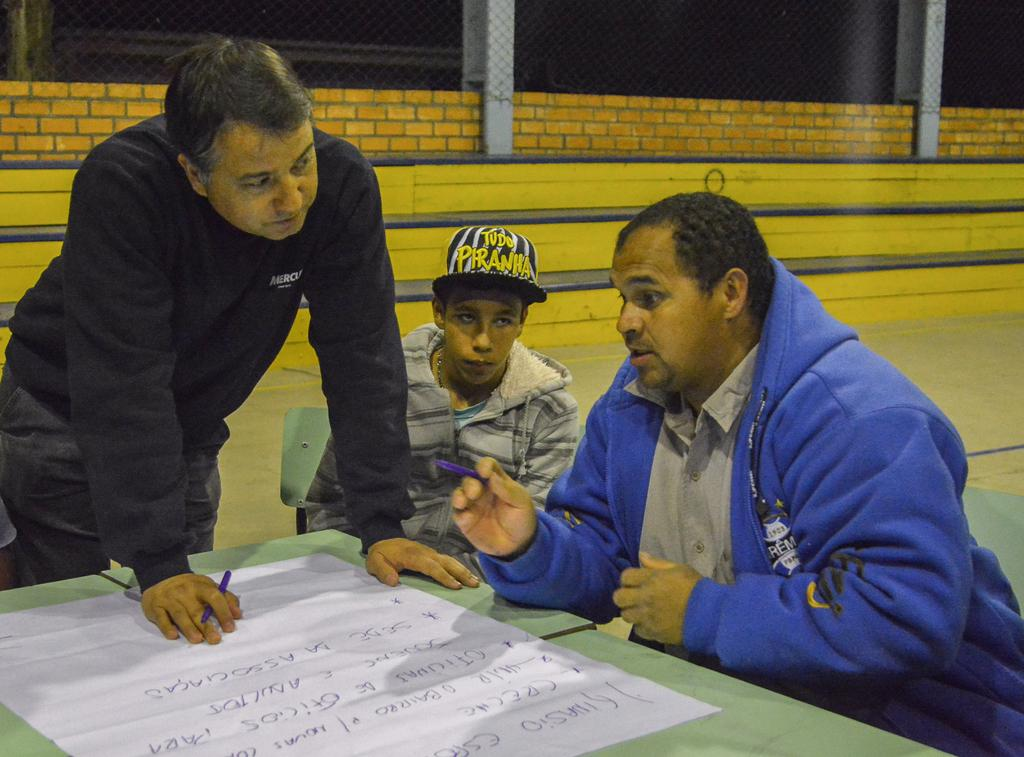What is on the table in the image? There is a paper on the table in the image. What is the person standing and holding doing? The person is standing and holding a pen. How many people are sitting in the image? There are two persons sitting on chairs in the image. What can be seen in the background of the image? There is a wire fence in the background. Can you see any ducks in the tub in the image? There is no tub or duck present in the image. How many stitches are visible on the person standing and holding a pen? The person standing and holding a pen is not depicted as having any visible stitches. 